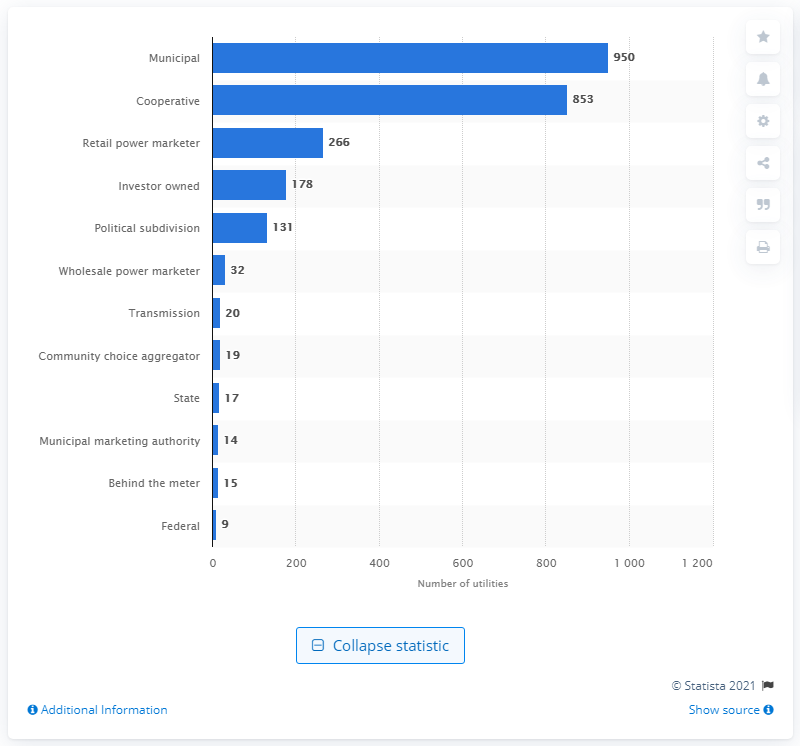Outline some significant characteristics in this image. There were 950 municipal utilities in the United States in 2019. There were 853 cooperative utilities in the United States in 2019. 